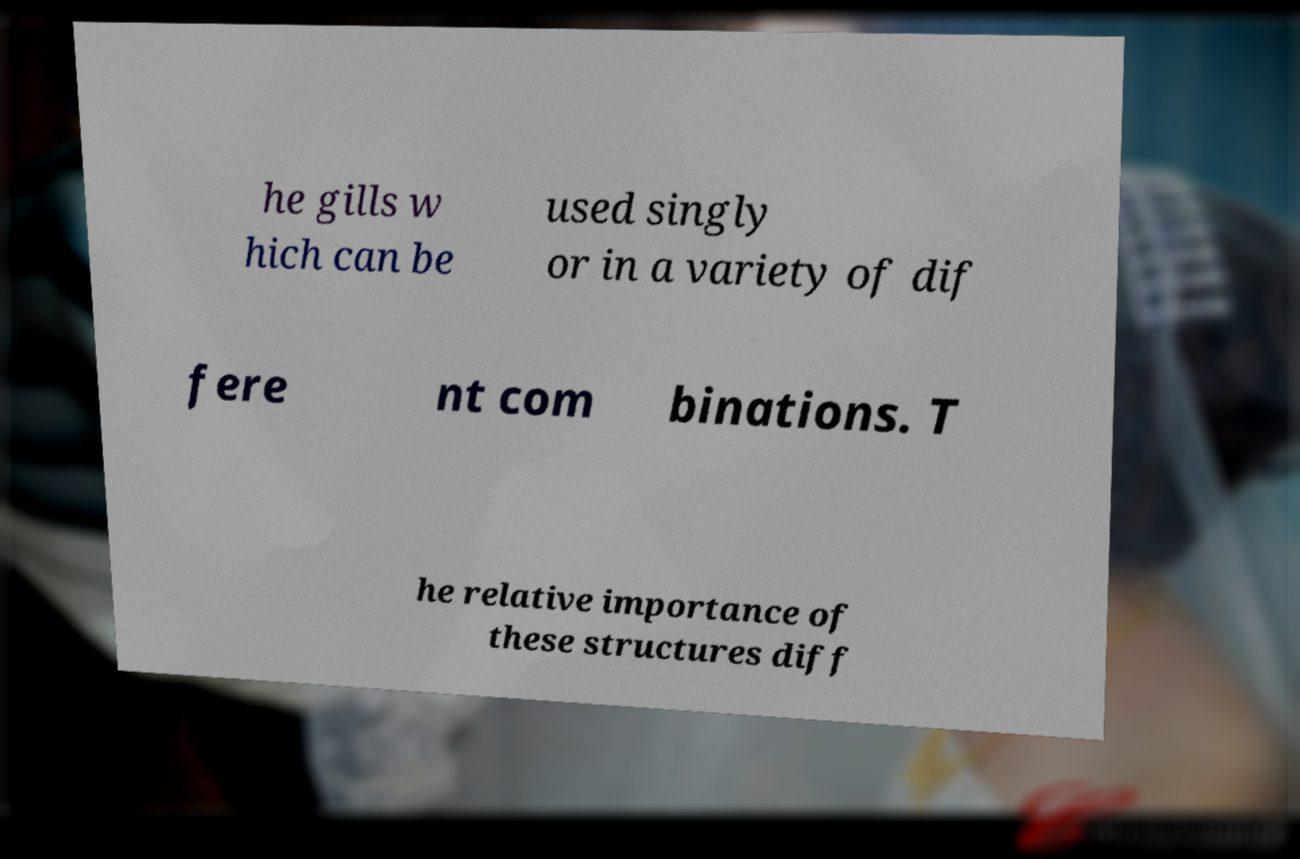Can you accurately transcribe the text from the provided image for me? he gills w hich can be used singly or in a variety of dif fere nt com binations. T he relative importance of these structures diff 